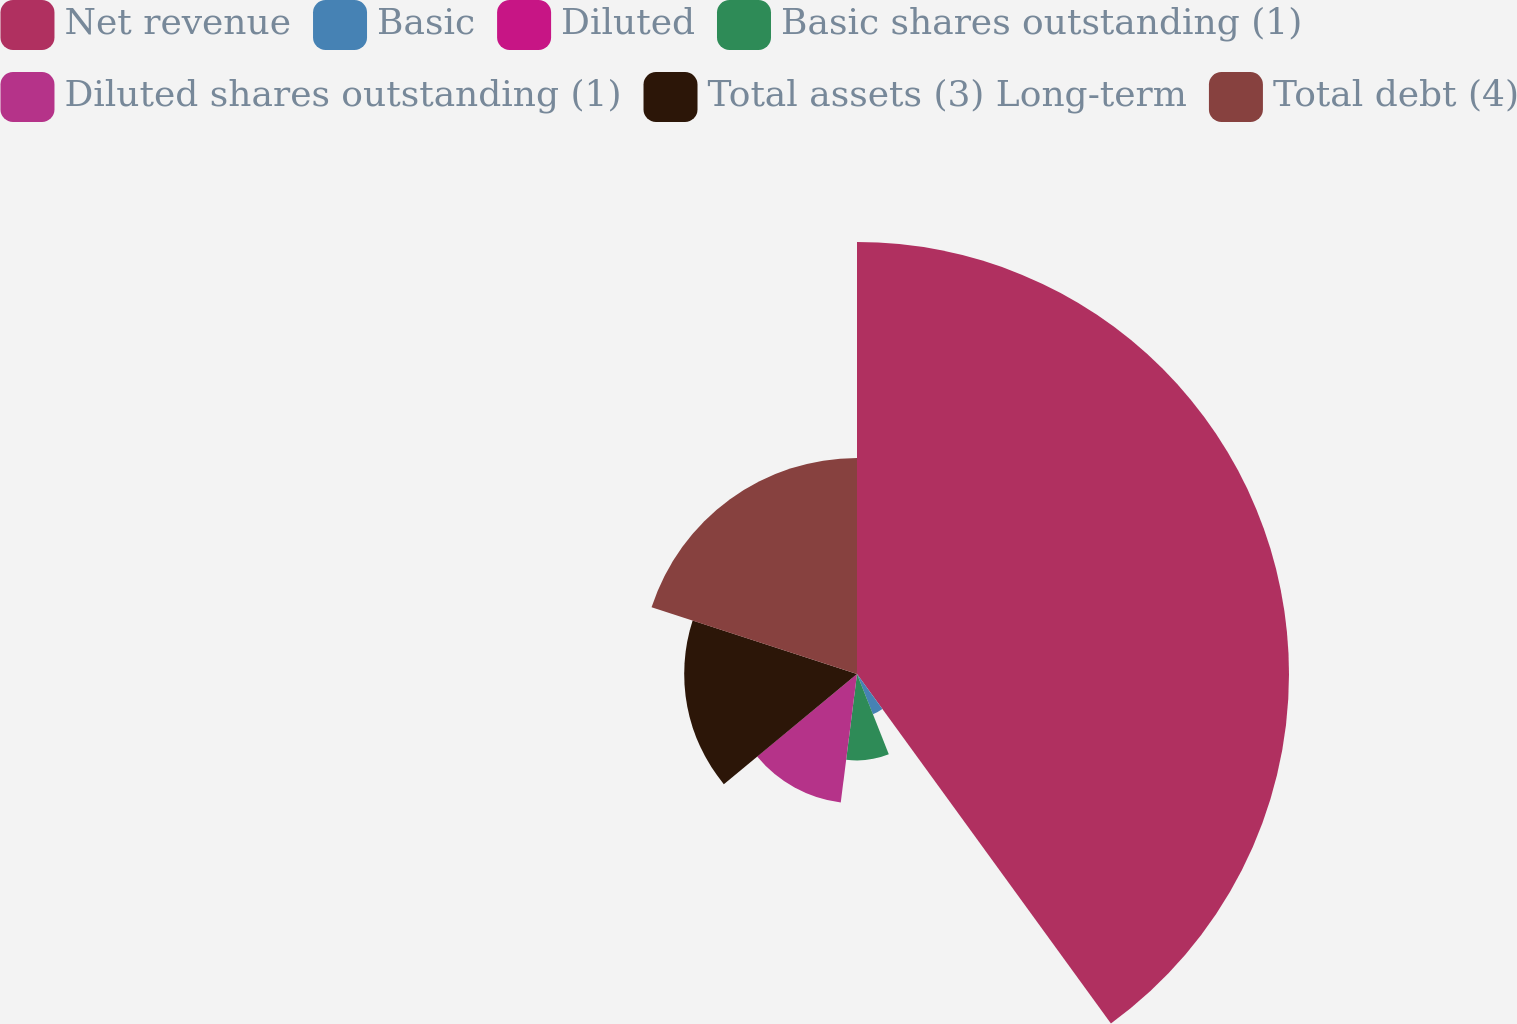Convert chart. <chart><loc_0><loc_0><loc_500><loc_500><pie_chart><fcel>Net revenue<fcel>Basic<fcel>Diluted<fcel>Basic shares outstanding (1)<fcel>Diluted shares outstanding (1)<fcel>Total assets (3) Long-term<fcel>Total debt (4)<nl><fcel>40.0%<fcel>4.0%<fcel>0.0%<fcel>8.0%<fcel>12.0%<fcel>16.0%<fcel>20.0%<nl></chart> 